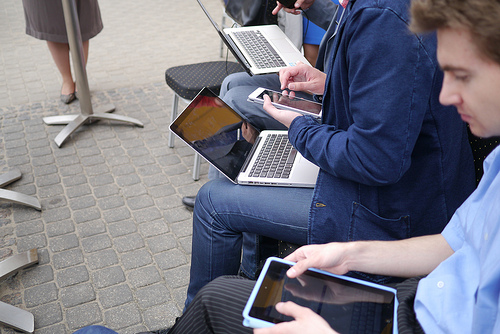What type of devices are visible in this image? The image offers a view of multiple electronic devices, including at least three laptops, likely engaged in business or networking activities. 